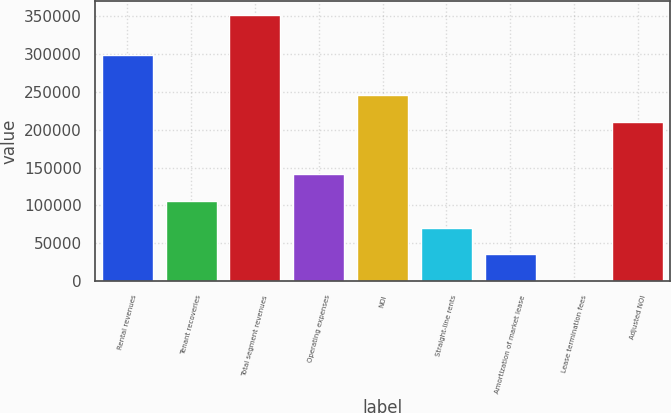<chart> <loc_0><loc_0><loc_500><loc_500><bar_chart><fcel>Rental revenues<fcel>Tenant recoveries<fcel>Total segment revenues<fcel>Operating expenses<fcel>NOI<fcel>Straight-line rents<fcel>Amortization of market lease<fcel>Lease termination fees<fcel>Adjusted NOI<nl><fcel>299102<fcel>105716<fcel>352334<fcel>140947<fcel>246042<fcel>70485.2<fcel>35254.1<fcel>23<fcel>210811<nl></chart> 